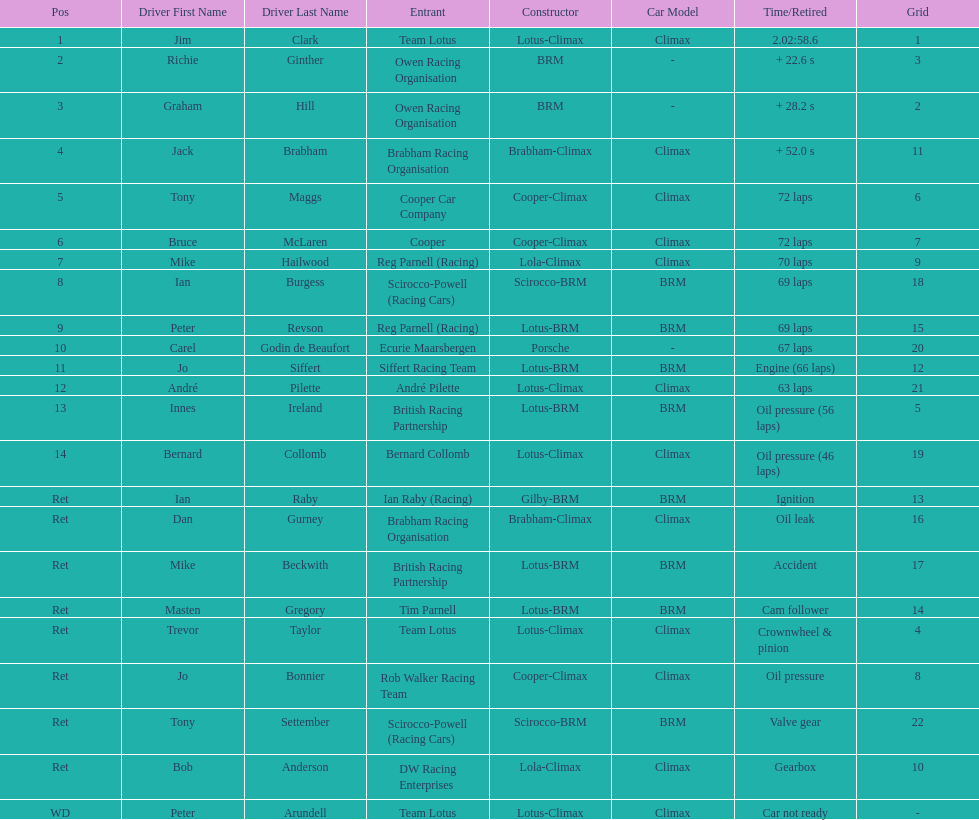How many different drivers are listed? 23. 